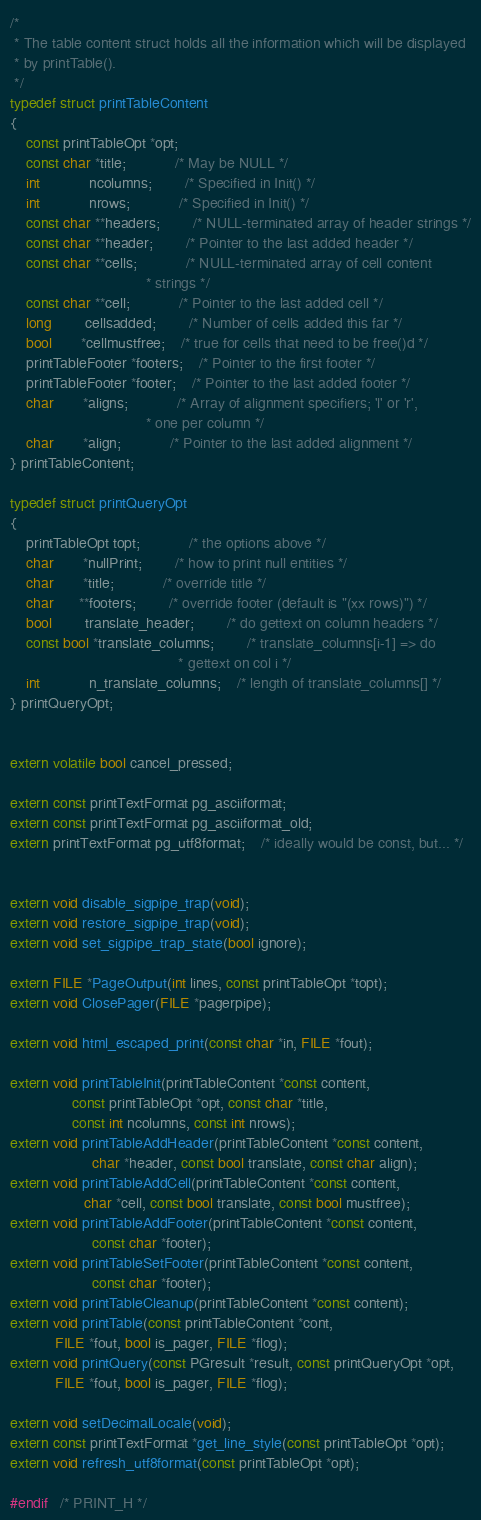Convert code to text. <code><loc_0><loc_0><loc_500><loc_500><_C_>/*
 * The table content struct holds all the information which will be displayed
 * by printTable().
 */
typedef struct printTableContent
{
	const printTableOpt *opt;
	const char *title;			/* May be NULL */
	int			ncolumns;		/* Specified in Init() */
	int			nrows;			/* Specified in Init() */
	const char **headers;		/* NULL-terminated array of header strings */
	const char **header;		/* Pointer to the last added header */
	const char **cells;			/* NULL-terminated array of cell content
								 * strings */
	const char **cell;			/* Pointer to the last added cell */
	long		cellsadded;		/* Number of cells added this far */
	bool	   *cellmustfree;	/* true for cells that need to be free()d */
	printTableFooter *footers;	/* Pointer to the first footer */
	printTableFooter *footer;	/* Pointer to the last added footer */
	char	   *aligns;			/* Array of alignment specifiers; 'l' or 'r',
								 * one per column */
	char	   *align;			/* Pointer to the last added alignment */
} printTableContent;

typedef struct printQueryOpt
{
	printTableOpt topt;			/* the options above */
	char	   *nullPrint;		/* how to print null entities */
	char	   *title;			/* override title */
	char	  **footers;		/* override footer (default is "(xx rows)") */
	bool		translate_header;		/* do gettext on column headers */
	const bool *translate_columns;		/* translate_columns[i-1] => do
										 * gettext on col i */
	int			n_translate_columns;	/* length of translate_columns[] */
} printQueryOpt;


extern volatile bool cancel_pressed;

extern const printTextFormat pg_asciiformat;
extern const printTextFormat pg_asciiformat_old;
extern printTextFormat pg_utf8format;	/* ideally would be const, but... */


extern void disable_sigpipe_trap(void);
extern void restore_sigpipe_trap(void);
extern void set_sigpipe_trap_state(bool ignore);

extern FILE *PageOutput(int lines, const printTableOpt *topt);
extern void ClosePager(FILE *pagerpipe);

extern void html_escaped_print(const char *in, FILE *fout);

extern void printTableInit(printTableContent *const content,
			   const printTableOpt *opt, const char *title,
			   const int ncolumns, const int nrows);
extern void printTableAddHeader(printTableContent *const content,
					char *header, const bool translate, const char align);
extern void printTableAddCell(printTableContent *const content,
				  char *cell, const bool translate, const bool mustfree);
extern void printTableAddFooter(printTableContent *const content,
					const char *footer);
extern void printTableSetFooter(printTableContent *const content,
					const char *footer);
extern void printTableCleanup(printTableContent *const content);
extern void printTable(const printTableContent *cont,
		   FILE *fout, bool is_pager, FILE *flog);
extern void printQuery(const PGresult *result, const printQueryOpt *opt,
		   FILE *fout, bool is_pager, FILE *flog);

extern void setDecimalLocale(void);
extern const printTextFormat *get_line_style(const printTableOpt *opt);
extern void refresh_utf8format(const printTableOpt *opt);

#endif   /* PRINT_H */
</code> 